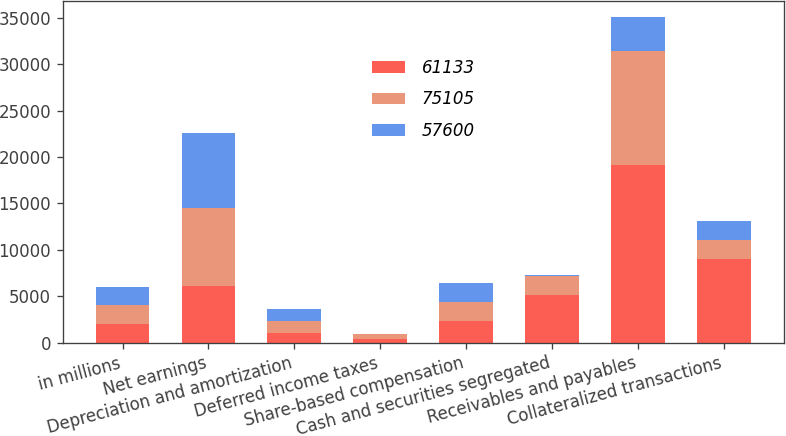<chart> <loc_0><loc_0><loc_500><loc_500><stacked_bar_chart><ecel><fcel>in millions<fcel>Net earnings<fcel>Depreciation and amortization<fcel>Deferred income taxes<fcel>Share-based compensation<fcel>Cash and securities segregated<fcel>Receivables and payables<fcel>Collateralized transactions<nl><fcel>61133<fcel>2015<fcel>6083<fcel>991<fcel>425<fcel>2272<fcel>5123<fcel>19132<fcel>9005<nl><fcel>75105<fcel>2014<fcel>8477<fcel>1337<fcel>495<fcel>2085<fcel>2046<fcel>12328<fcel>2030.5<nl><fcel>57600<fcel>2013<fcel>8040<fcel>1322<fcel>29<fcel>2015<fcel>143<fcel>3682<fcel>2030.5<nl></chart> 